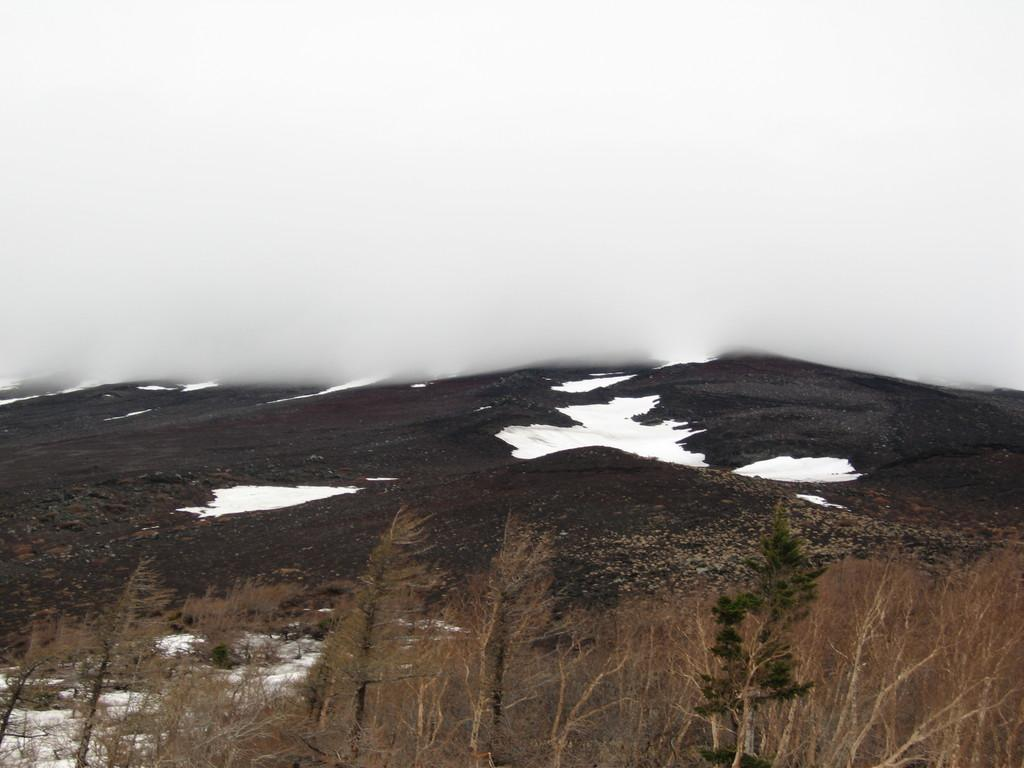What type of trees are in the image? There are dry trees in the image. What is covering the ground in the image? There is snow in the image. What color is the background of the image? The background of the image is white. How many brothers are standing next to the dry trees in the image? There are no brothers present in the image. What type of coat is the branch wearing in the image? There is no branch wearing a coat in the image, as branches are not capable of wearing clothing. 